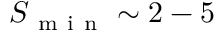<formula> <loc_0><loc_0><loc_500><loc_500>S _ { m i n } \sim 2 - 5</formula> 